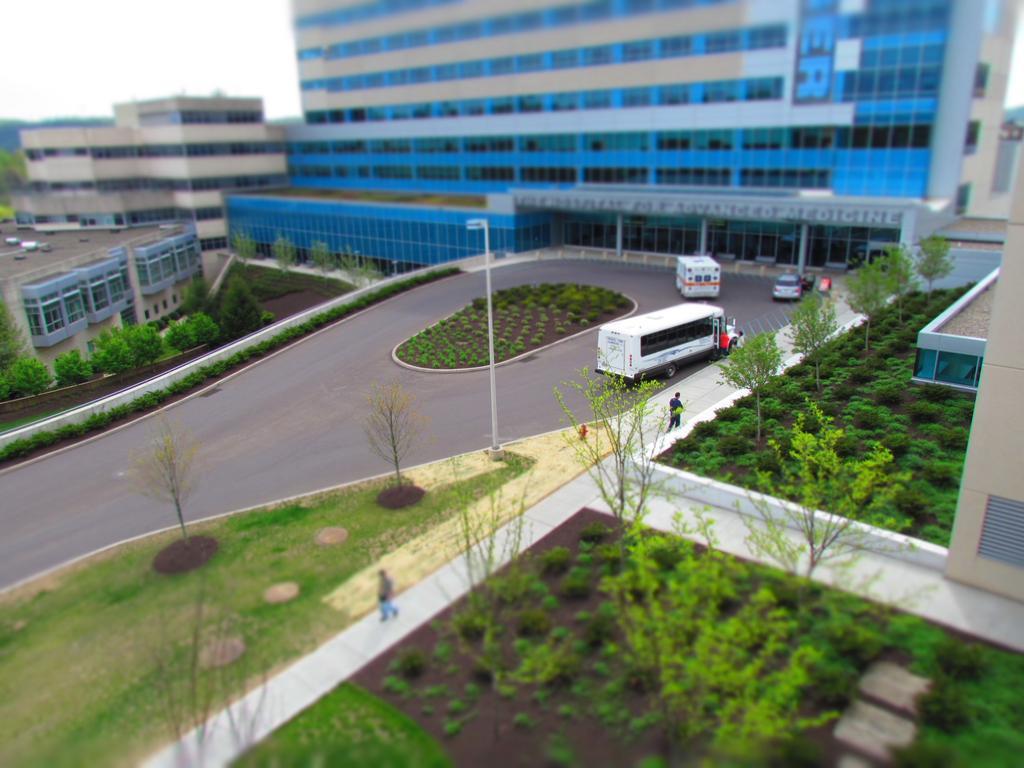How would you summarize this image in a sentence or two? This image is taken outdoors. At the bottom of the image there is a ground with grass, plants and a few trees on it and there is a road. In the background there are a few buildings with walls, windows, doors, balconies and roofs. On the right side of the image there is a house. In the middle of the image a few vehicles are moving on the road and there is a street light. Two men are walking on the road. 